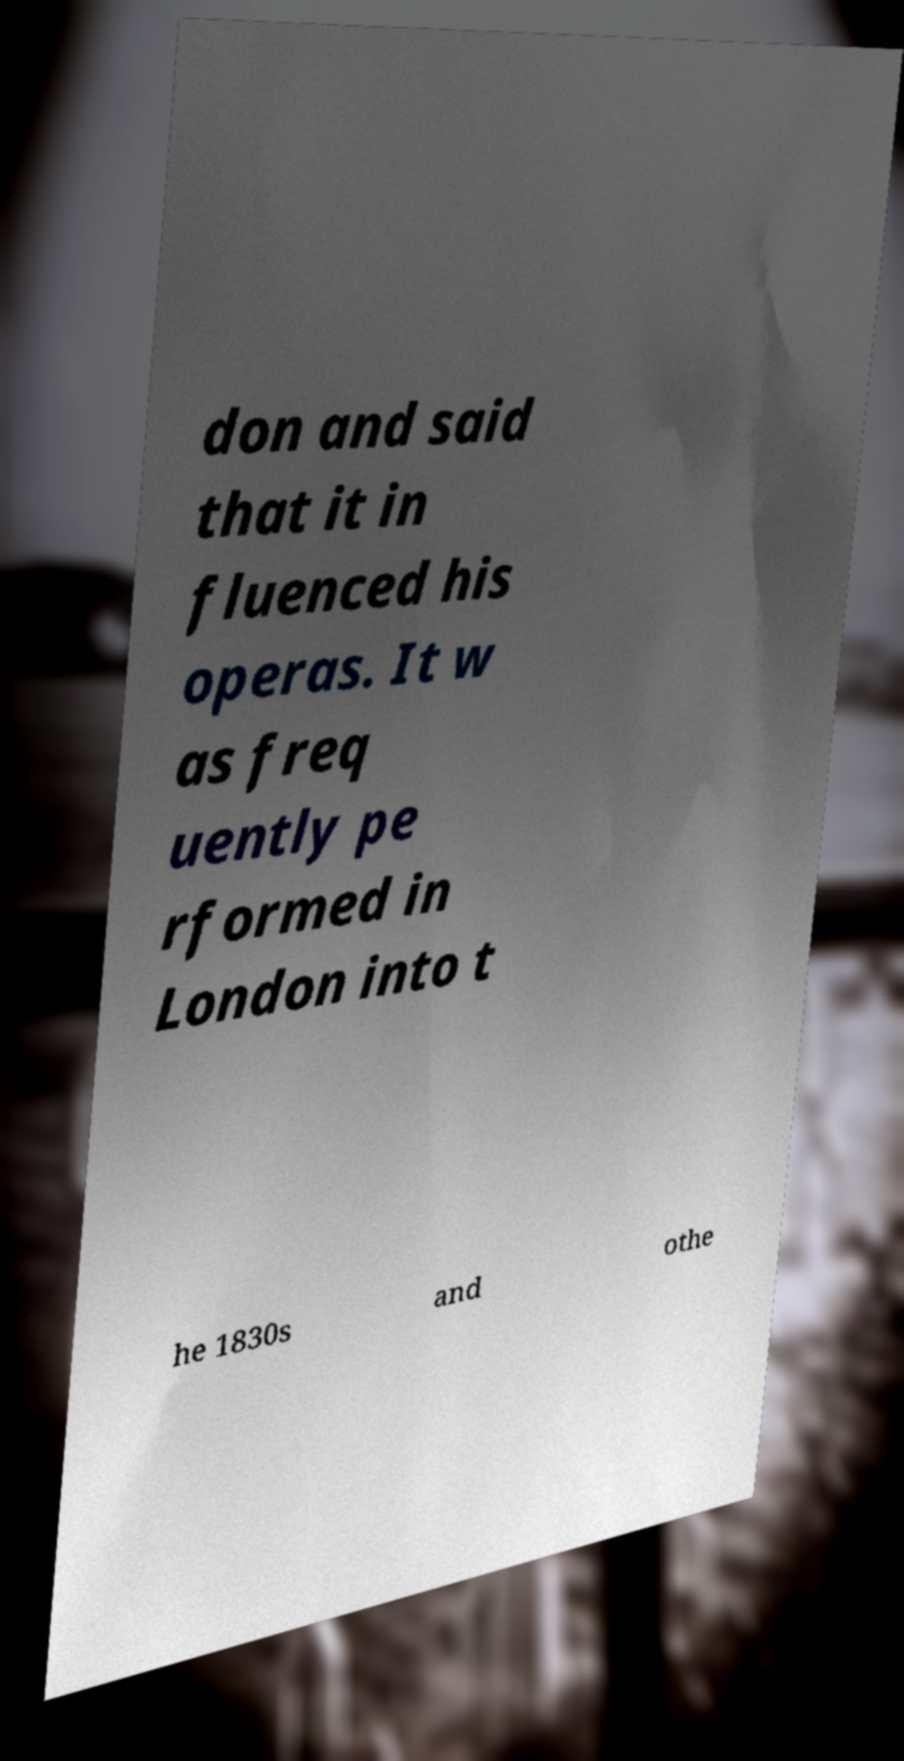Please read and relay the text visible in this image. What does it say? don and said that it in fluenced his operas. It w as freq uently pe rformed in London into t he 1830s and othe 